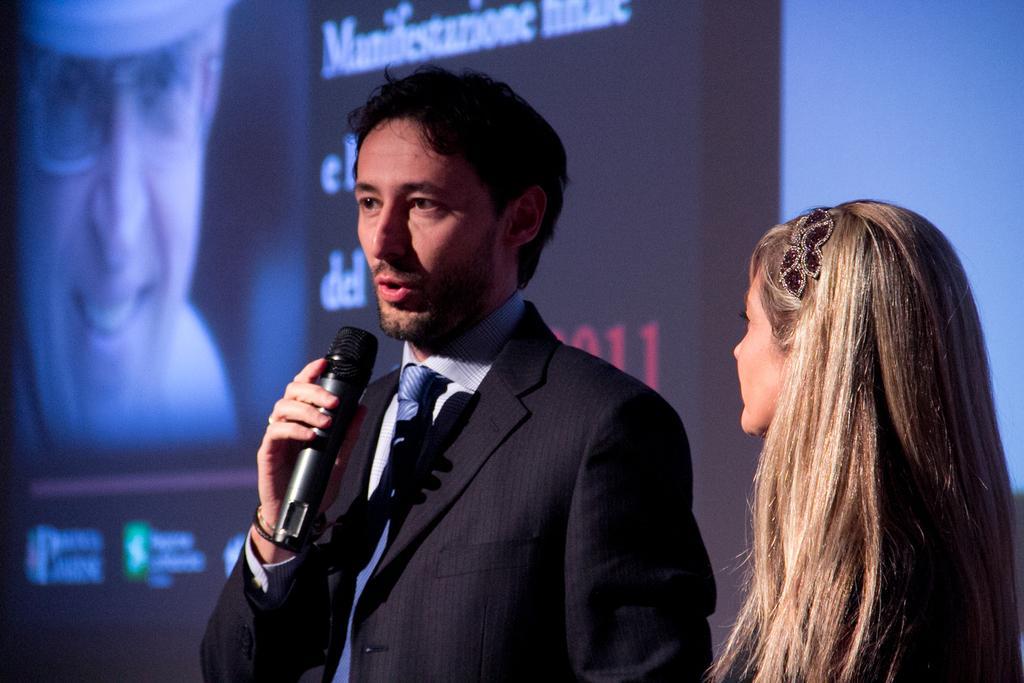Describe this image in one or two sentences. This picture shows a man and woman standing and we see a man speaking with the help of a microphone and we see a hoarding back of him 